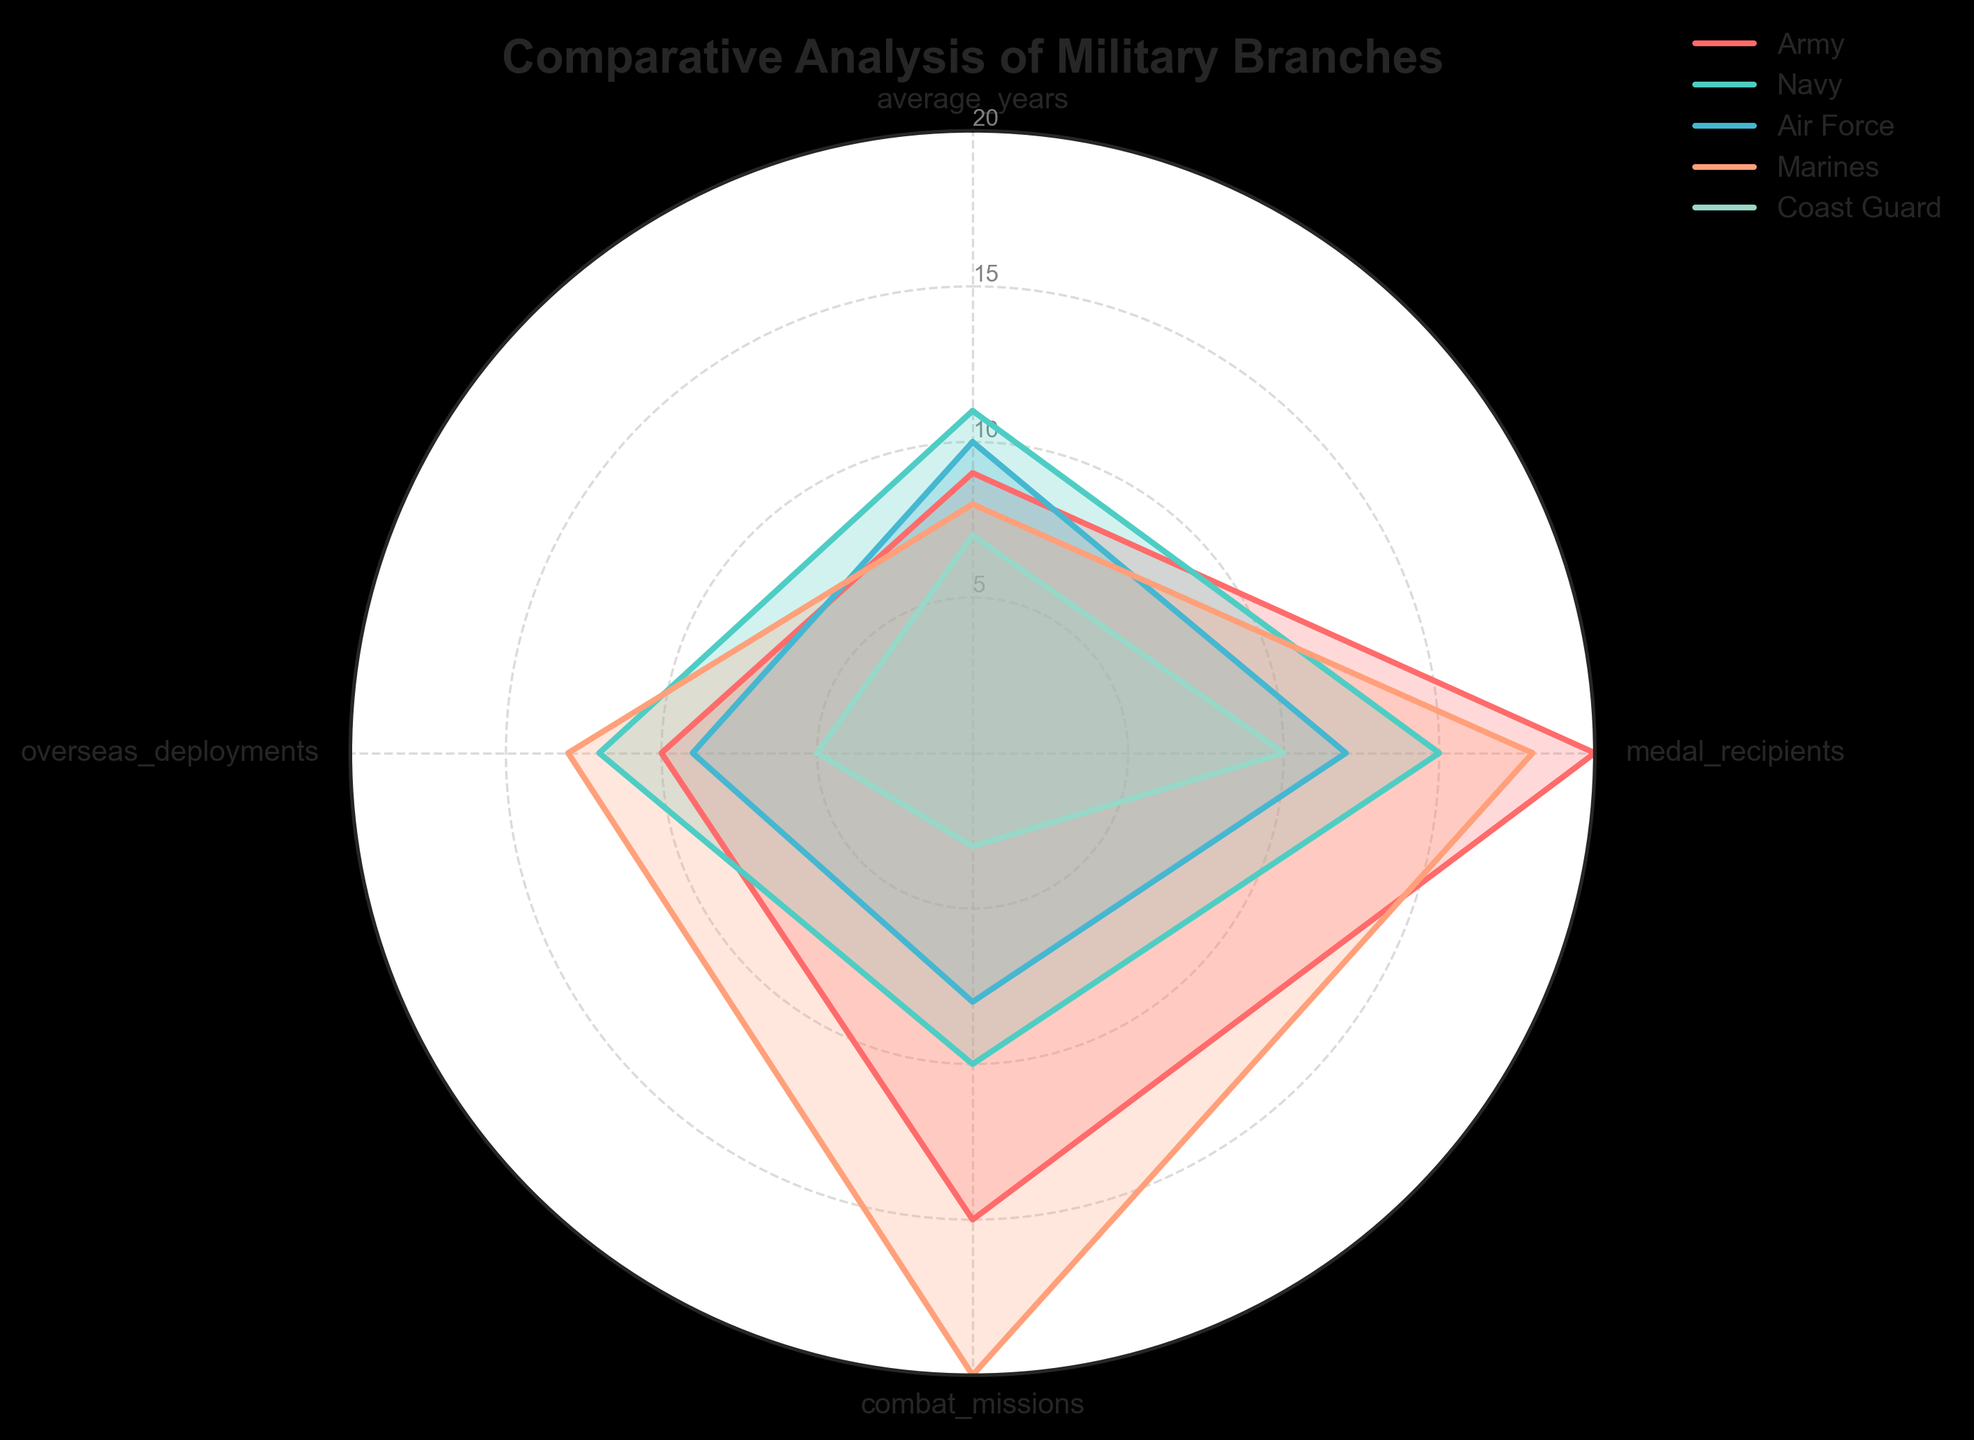What is the title of the radar chart? The title of the radar chart is generally written at the top of the chart in a bold and larger font. Looking at the figure, it shows "Comparative Analysis of Military Branches."
Answer: Comparative Analysis of Military Branches Which military branch has the highest value in overseas deployments? Only one data point is necessary. By examining the respective values of the branches in the "overseas deployments" category on the radar chart, we see that the Marines have the highest value with a score of 13.
Answer: Marines Which two military branches have the closest values in combat missions? By comparing the values in the "combat missions" category on the radar chart, the Air Force (8) and Navy (10) are the closest with a difference of only 2 units.
Answer: Air Force and Navy What branch has the lowest average years of service? On the radar chart, we can look at the "average_years" category and notice that the Coast Guard has the smallest value, which is 7 years.
Answer: Coast Guard How many military branches have their number of medal recipients higher than 15? By identifying the values in the "medal_recipients" category, we see that the Army (20), Marines (18), and Navy (15) qualify. Thus, three branches have recipients higher than 15, inclusive of 15.
Answer: 3 Is there any category where all branches score less than 20? Examining all the categories in the radar chart, we observe that in the "combat missions" category, no branch scores 20 or higher, indicating that all branches score less than 20 here.
Answer: Yes, combat missions Which branch has consistently high values (greater than 10) across all categories? By evaluating each category for values higher than 10, the Marines have values of 8, 18, 20, and 13, which indicates a consistent trend though not always exceeding a value of 10 in every category.
Answer: None Among the branches, which one has the largest difference between the number of medal recipients and combat missions? Subtracting the combat mission values from the medal recipients, the Marines have 18 - 20 = -2 while the largest difference is for the Army with 20 - 15 = 5, yielding a difference of 5, making it the highest compared to other branches.
Answer: Army Out of the five military branches, which one ranks highest only in one category? The radar chart indicates the peak scores per category, revealing the Air Force peaks on the "average_years" category only with no other maxima in other categories.
Answer: Air Force 